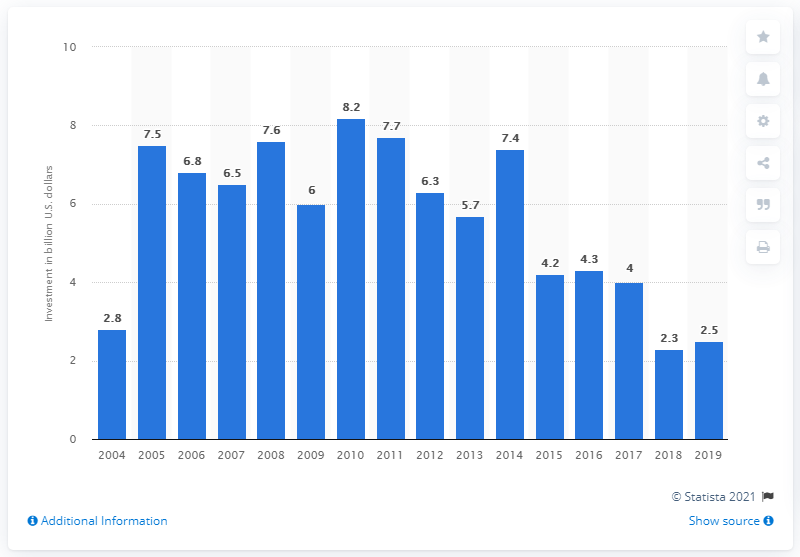Specify some key components in this picture. In 2017, the world invested approximately 2.5 billion U.S. dollars in small hydropower technologies. The world invested approximately 2.5 billion US dollars in small hydropower technologies in 2019. 